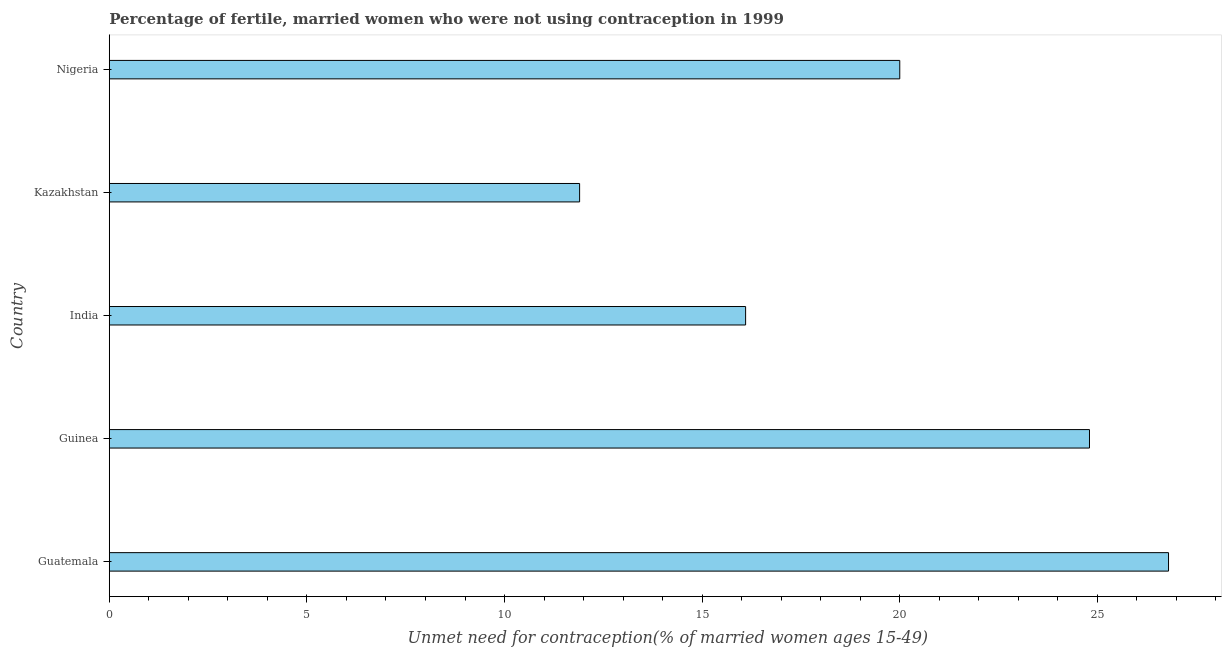What is the title of the graph?
Make the answer very short. Percentage of fertile, married women who were not using contraception in 1999. What is the label or title of the X-axis?
Provide a short and direct response.  Unmet need for contraception(% of married women ages 15-49). What is the label or title of the Y-axis?
Give a very brief answer. Country. What is the number of married women who are not using contraception in Kazakhstan?
Your answer should be very brief. 11.9. Across all countries, what is the maximum number of married women who are not using contraception?
Give a very brief answer. 26.8. Across all countries, what is the minimum number of married women who are not using contraception?
Your answer should be compact. 11.9. In which country was the number of married women who are not using contraception maximum?
Provide a succinct answer. Guatemala. In which country was the number of married women who are not using contraception minimum?
Give a very brief answer. Kazakhstan. What is the sum of the number of married women who are not using contraception?
Give a very brief answer. 99.6. What is the average number of married women who are not using contraception per country?
Keep it short and to the point. 19.92. What is the median number of married women who are not using contraception?
Your answer should be compact. 20. What is the ratio of the number of married women who are not using contraception in Guinea to that in India?
Give a very brief answer. 1.54. Is the sum of the number of married women who are not using contraception in Guatemala and Guinea greater than the maximum number of married women who are not using contraception across all countries?
Offer a terse response. Yes. What is the difference between the highest and the lowest number of married women who are not using contraception?
Offer a very short reply. 14.9. How many countries are there in the graph?
Make the answer very short. 5. Are the values on the major ticks of X-axis written in scientific E-notation?
Your answer should be very brief. No. What is the  Unmet need for contraception(% of married women ages 15-49) in Guatemala?
Make the answer very short. 26.8. What is the  Unmet need for contraception(% of married women ages 15-49) in Guinea?
Offer a terse response. 24.8. What is the  Unmet need for contraception(% of married women ages 15-49) of Kazakhstan?
Offer a terse response. 11.9. What is the difference between the  Unmet need for contraception(% of married women ages 15-49) in Guinea and India?
Your answer should be compact. 8.7. What is the difference between the  Unmet need for contraception(% of married women ages 15-49) in Guinea and Kazakhstan?
Keep it short and to the point. 12.9. What is the difference between the  Unmet need for contraception(% of married women ages 15-49) in Guinea and Nigeria?
Your answer should be compact. 4.8. What is the difference between the  Unmet need for contraception(% of married women ages 15-49) in India and Nigeria?
Give a very brief answer. -3.9. What is the ratio of the  Unmet need for contraception(% of married women ages 15-49) in Guatemala to that in Guinea?
Provide a short and direct response. 1.08. What is the ratio of the  Unmet need for contraception(% of married women ages 15-49) in Guatemala to that in India?
Provide a short and direct response. 1.67. What is the ratio of the  Unmet need for contraception(% of married women ages 15-49) in Guatemala to that in Kazakhstan?
Offer a very short reply. 2.25. What is the ratio of the  Unmet need for contraception(% of married women ages 15-49) in Guatemala to that in Nigeria?
Your answer should be compact. 1.34. What is the ratio of the  Unmet need for contraception(% of married women ages 15-49) in Guinea to that in India?
Provide a short and direct response. 1.54. What is the ratio of the  Unmet need for contraception(% of married women ages 15-49) in Guinea to that in Kazakhstan?
Your answer should be very brief. 2.08. What is the ratio of the  Unmet need for contraception(% of married women ages 15-49) in Guinea to that in Nigeria?
Give a very brief answer. 1.24. What is the ratio of the  Unmet need for contraception(% of married women ages 15-49) in India to that in Kazakhstan?
Offer a very short reply. 1.35. What is the ratio of the  Unmet need for contraception(% of married women ages 15-49) in India to that in Nigeria?
Offer a very short reply. 0.81. What is the ratio of the  Unmet need for contraception(% of married women ages 15-49) in Kazakhstan to that in Nigeria?
Your response must be concise. 0.59. 